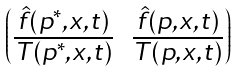Convert formula to latex. <formula><loc_0><loc_0><loc_500><loc_500>\begin{pmatrix} \frac { \hat { f } ( p ^ { * } , x , t ) } { T ( p ^ { * } , x , t ) } & \frac { \hat { f } ( p , x , t ) } { T ( p , x , t ) } \end{pmatrix}</formula> 